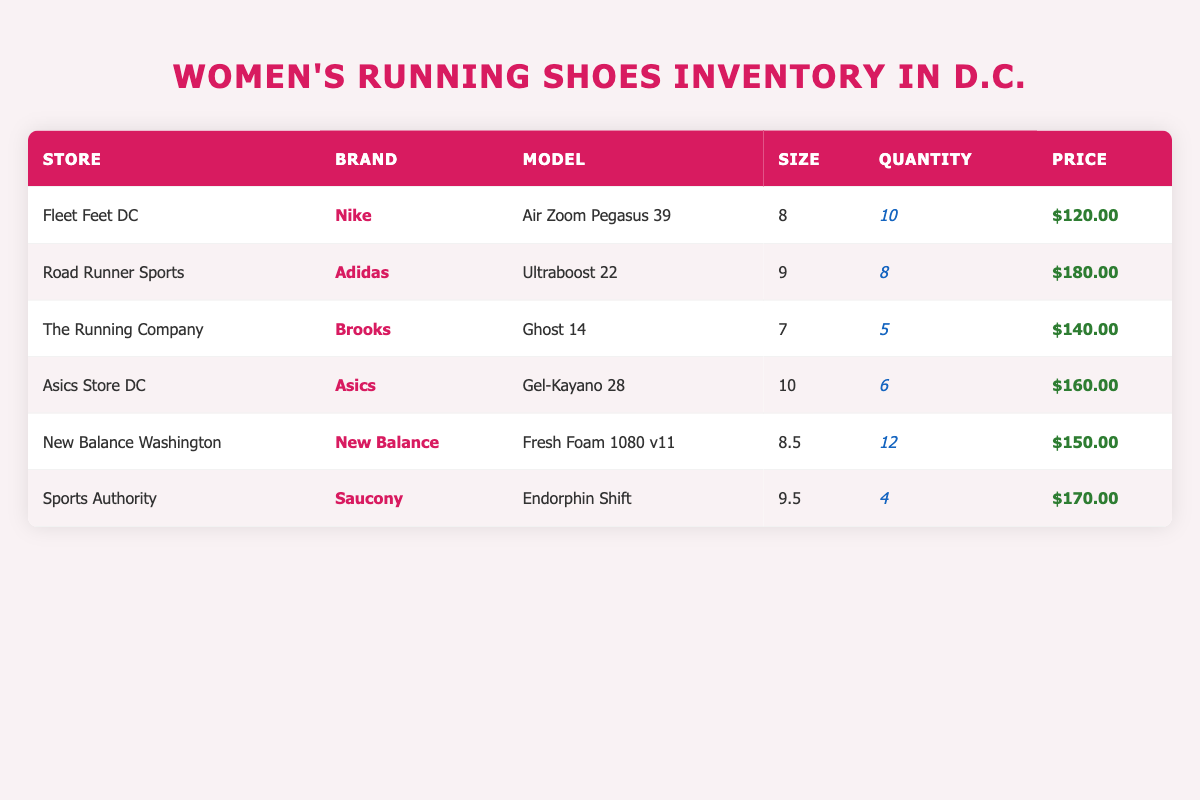What brand has the lowest quantity available in the inventory? By observing the quantities listed for each brand, we identify that the Saucony 'Endorphin Shift' has the lowest quantity available, which is 4 pairs.
Answer: Saucony Which shoe model from New Balance has the highest quantity available? We see the New Balance 'Fresh Foam 1080 v11' with a quantity of 12 pairs, which is the highest among the options listed in the table.
Answer: Fresh Foam 1080 v11 What is the total price for all available quantities of Nike shoes? The Nike 'Air Zoom Pegasus 39' has 10 pairs available at a price of $120 each. Therefore, the total price is calculated as 10 * 120 = 1200.
Answer: 1200 Is there any shoe model available in a size that is not a whole number? The New Balance 'Fresh Foam 1080 v11' is listed in size 8.5, which is not a whole number.
Answer: Yes What is the average price of the running shoes listed in the inventory? The prices of the shoes are 120, 180, 140, 160, 150, and 170. To find the average, we sum these prices giving us 1020 (120 + 180 + 140 + 160 + 150 + 170) and divide by the number of models (6), resulting in 1020 / 6 = 170.
Answer: 170 Which store offers the most expensive model based on the listed prices? Looking through the prices, Adidas 'Ultraboost 22' at $180 is the most expensive model available across all stores.
Answer: Road Runner Sports What size of Brooks shoes is available, and how many pairs do they have? We can check for Brooks shoes in the inventory and find that the 'Ghost 14' is available in size 7 with a total of 5 pairs.
Answer: Size 7, 5 pairs Are there any stores that have an available quantity of 10 or more shoes? Yes, Fleet Feet DC has 10 pairs of the Nike 'Air Zoom Pegasus 39' and New Balance Washington has 12 pairs of the 'Fresh Foam 1080 v11', indicating there are stores with a quantity of 10 or more shoes.
Answer: Yes 